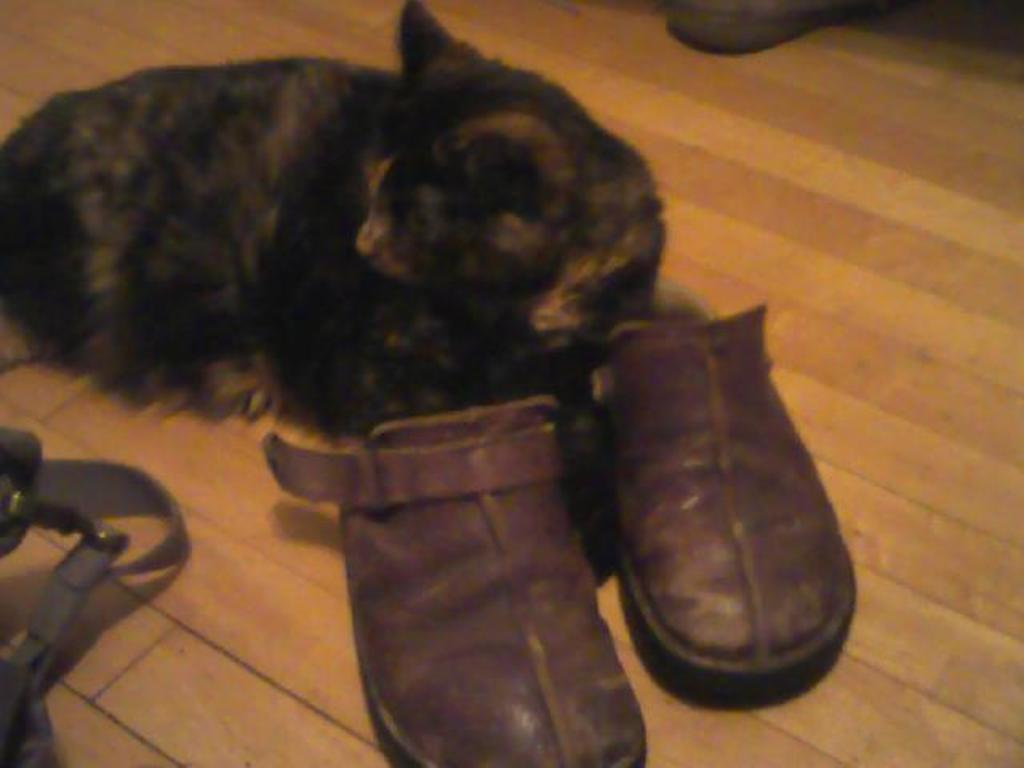What type of animal is in the picture? There is a cat in the picture. What can be seen on the floor in the picture? There is a pair of shoes on the floor in the picture. Can you describe the two unspecified objects in the picture? Unfortunately, the facts provided do not give any details about the two unspecified objects in the picture. What attempt does the cat make in the picture? There is no indication in the picture that the cat is attempting anything. 